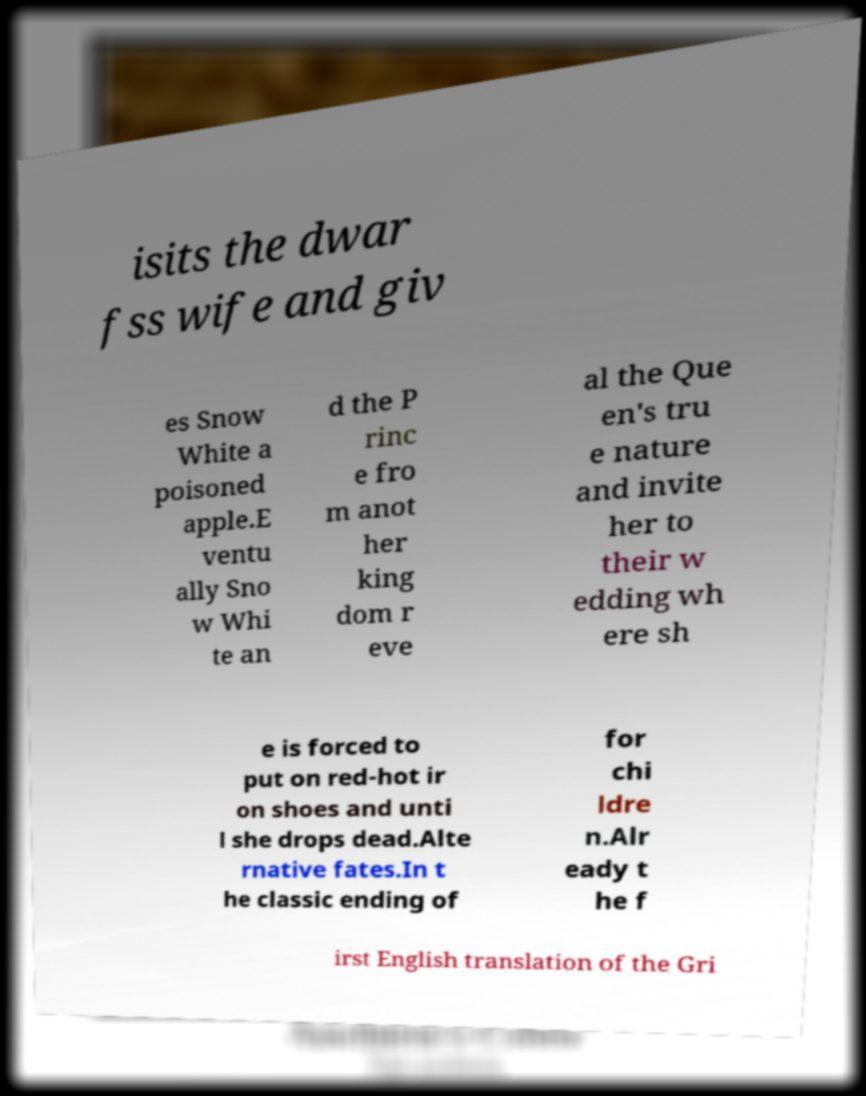Could you assist in decoding the text presented in this image and type it out clearly? isits the dwar fss wife and giv es Snow White a poisoned apple.E ventu ally Sno w Whi te an d the P rinc e fro m anot her king dom r eve al the Que en's tru e nature and invite her to their w edding wh ere sh e is forced to put on red-hot ir on shoes and unti l she drops dead.Alte rnative fates.In t he classic ending of for chi ldre n.Alr eady t he f irst English translation of the Gri 